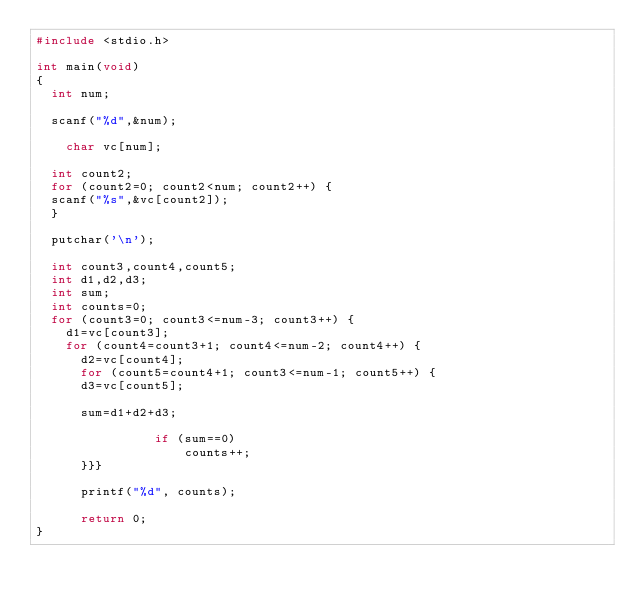Convert code to text. <code><loc_0><loc_0><loc_500><loc_500><_C_>#include <stdio.h>

int main(void)
{
	int num;
	
	scanf("%d",&num);
    
    char vc[num];
	
	int count2;
	for (count2=0; count2<num; count2++) {
	scanf("%s",&vc[count2]);
	}
	
	putchar('\n');
	
	int count3,count4,count5;
	int d1,d2,d3;
	int sum;
	int counts=0;
	for (count3=0; count3<=num-3; count3++) {
		d1=vc[count3];
		for (count4=count3+1; count4<=num-2; count4++) {
			d2=vc[count4];
			for (count5=count4+1; count3<=num-1; count5++) {
			d3=vc[count5];
			
			sum=d1+d2+d3;
			
                if (sum==0)
                    counts++;
			}}}
			
			printf("%d", counts);
			
			return 0;
}</code> 